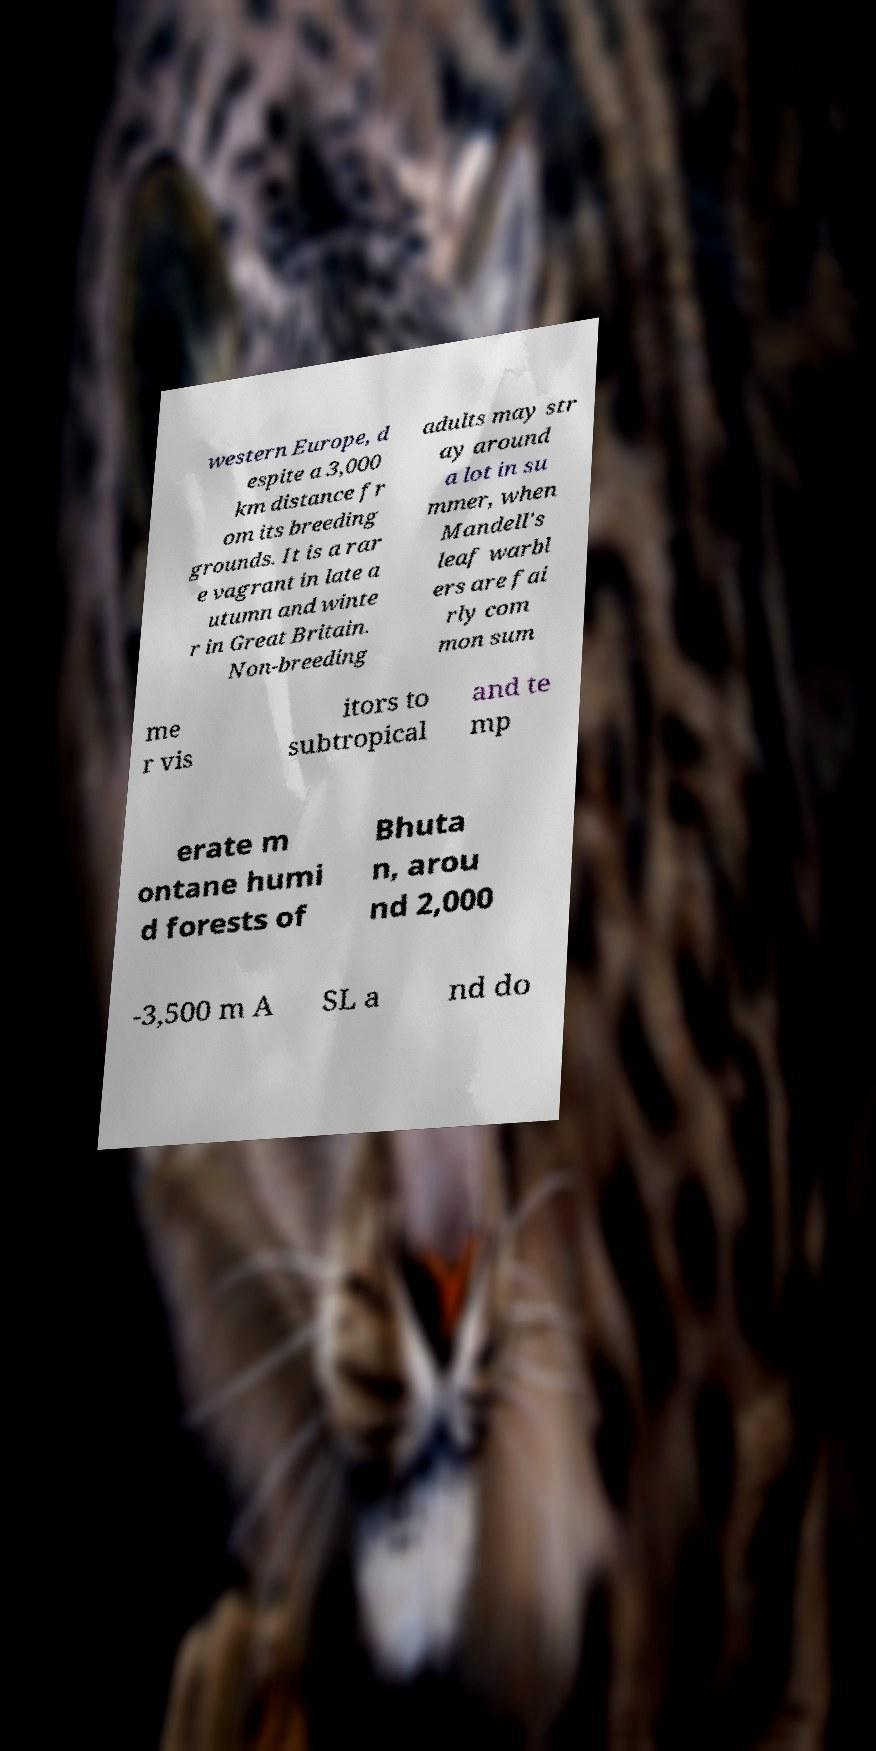For documentation purposes, I need the text within this image transcribed. Could you provide that? western Europe, d espite a 3,000 km distance fr om its breeding grounds. It is a rar e vagrant in late a utumn and winte r in Great Britain. Non-breeding adults may str ay around a lot in su mmer, when Mandell's leaf warbl ers are fai rly com mon sum me r vis itors to subtropical and te mp erate m ontane humi d forests of Bhuta n, arou nd 2,000 -3,500 m A SL a nd do 